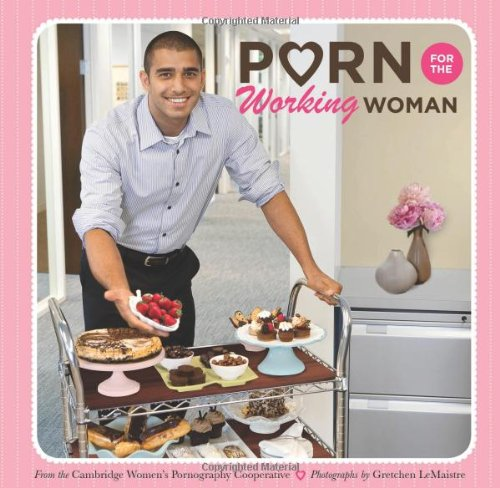Can you describe the setting depicted in the cover image? The cover features a smiling man presenting a variety of desserts on a serving cart in a well-decorated room with neutral colors and subtle floral decor, creating a warm, inviting atmosphere. 